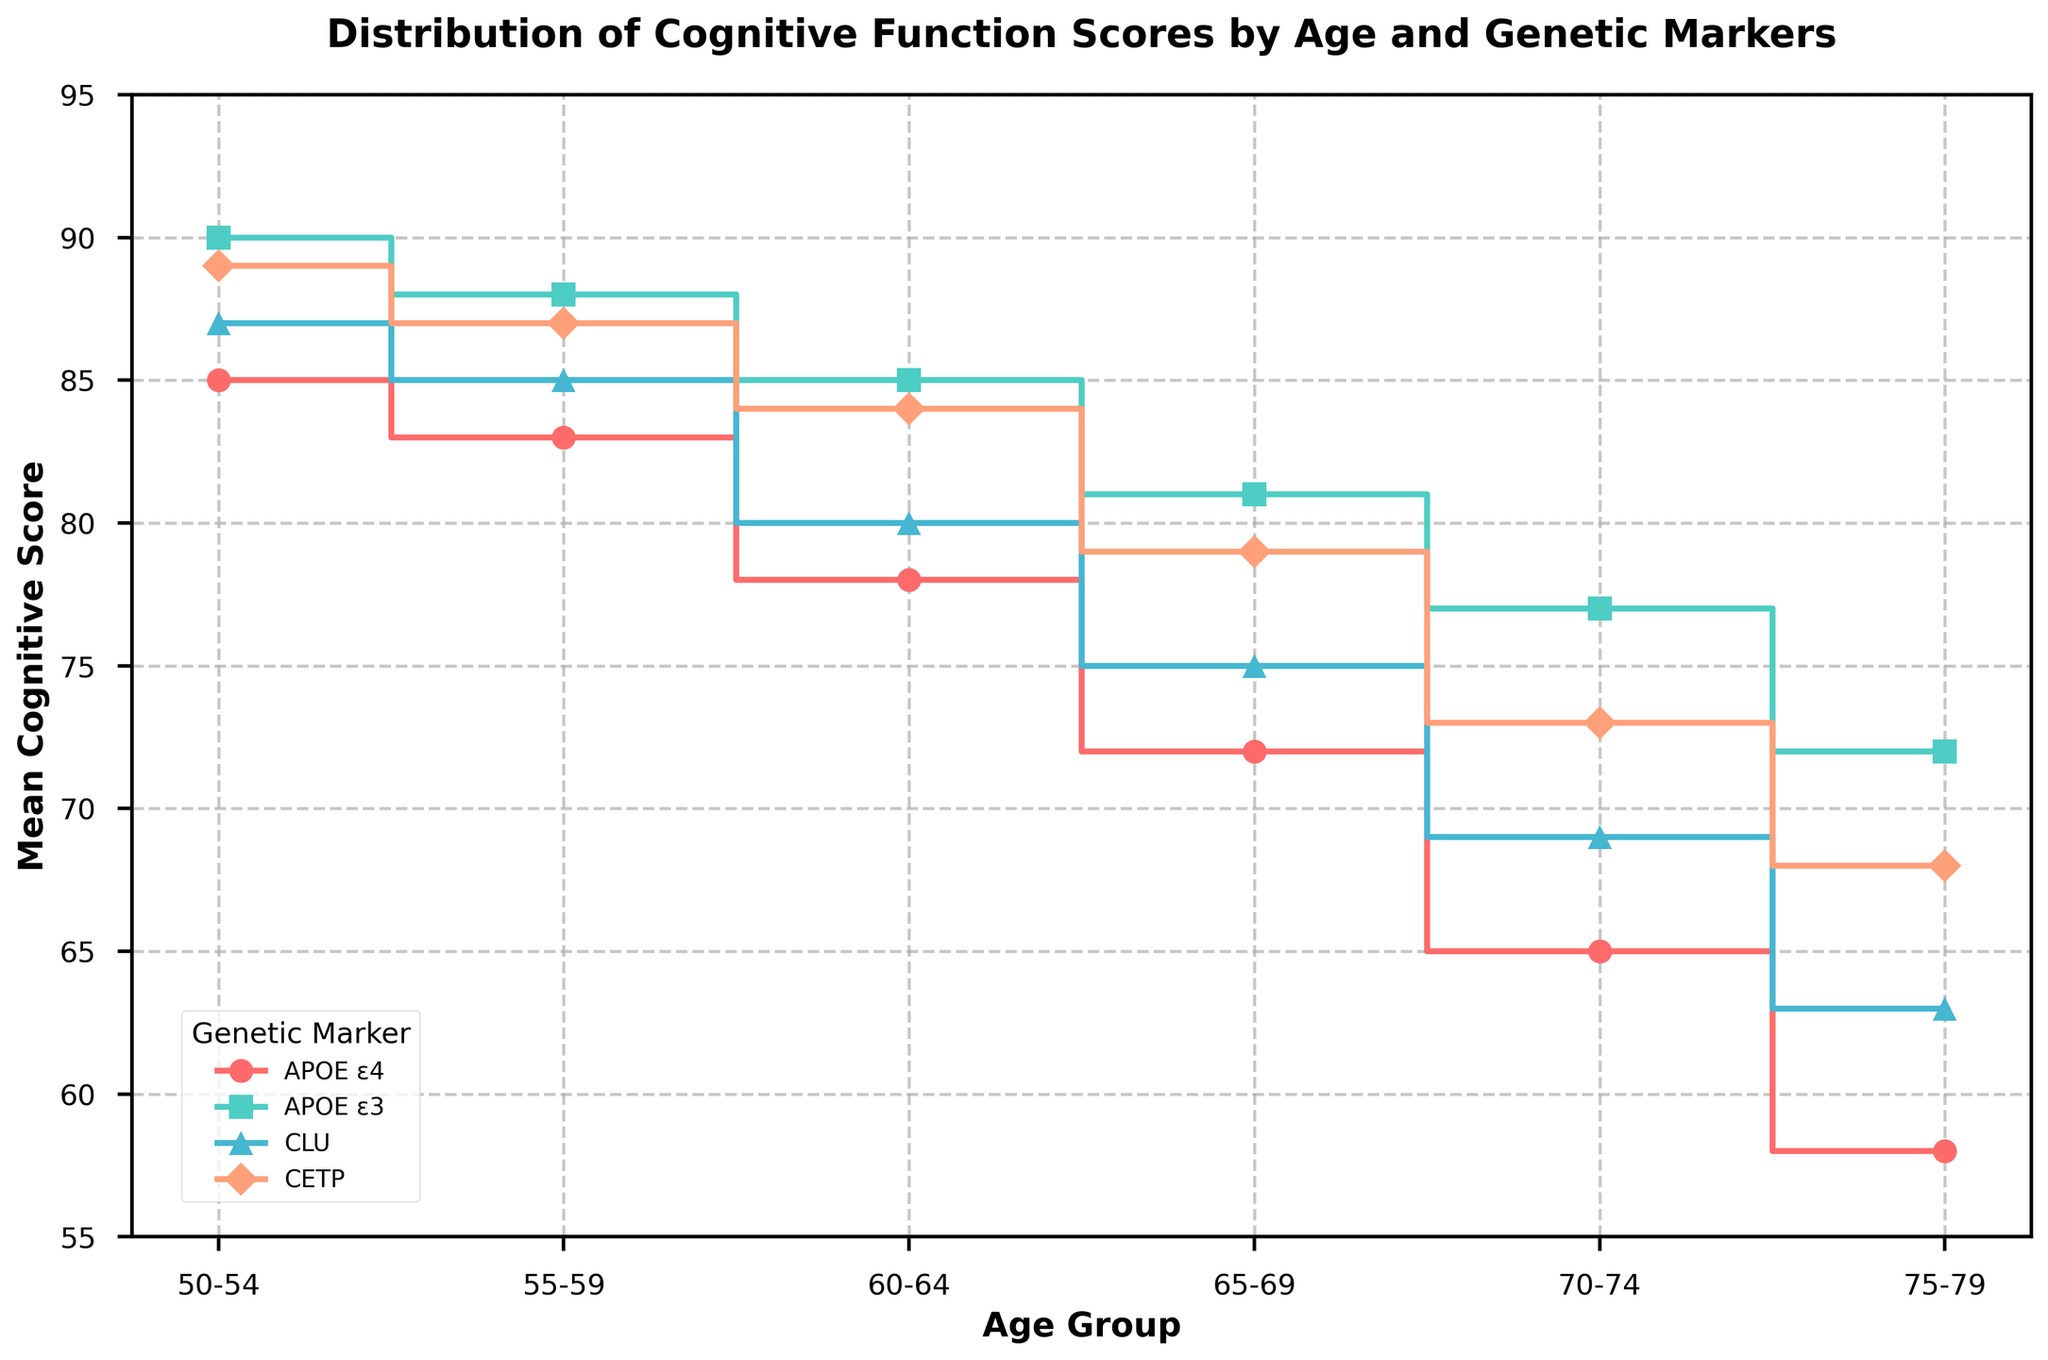What's the title of the plot? The title is displayed at the top of the figure and serves to describe the content of the plot. In this case, it is the only large text at the very top.
Answer: Distribution of Cognitive Function Scores by Age and Genetic Markers At what age group is the cognitive score the highest for APOE ε3? The cognitive scores for APOE ε3 must be examined across all age groups. The highest value is 90, which occurs at the age group 50-54.
Answer: 50-54 What is the overall trend of the cognitive scores for the genetic marker APOE ε4 across different age groups? Starting from the youngest age group, the cognitive scores for APOE ε4 decrease as the age groups progress.
Answer: Decreasing trend How do the cognitive scores of CETP compare to those of APOE ε4 at the age group 65-69? Locate the cognitive scores for APOE ε4 and CETP at age group 65-69. For APOE ε4, it is 72, and for CETP, it is 79. Comparing the two, CETP has a higher cognitive score.
Answer: CETP is higher than APOE ε4 By how much does the cognitive score for CLU decrease from age group 60-64 to age group 70-74? Note the cognitive scores for CLU at both 60-64 and 70-74, which are 80 and 69 respectively. The difference is then calculated: 80 - 69.
Answer: 11 points Which genetic marker has the smallest decline in cognitive scores from age group 55-59 to age group 60-64? Calculate the change in scores for each marker from 55-59 to 60-64. APOE ε4: 83 to 78 (-5), APOE ε3: 88 to 85 (-3), CLU: 85 to 80 (-5), CETP: 87 to 84 (-3). The smallest decline is shared by APOE ε3 and CETP.
Answer: APOE ε3 and CETP Is there any age group where all genetic markers have cognitive scores higher than 70? Inspect each age group and check if all markers have scores above 70. Age groups 50-54, 55-59, and 60-64 satisfy this condition.
Answer: Yes, 50-54, 55-59, 60-64 What's the color associated with the genetic marker CLU in the plot? The plot uses different colors for different genetic markers. The color for CLU is visually confirmed from the plot legend, identified as a shade between blue and cyan.
Answer: blue/cyan shade 